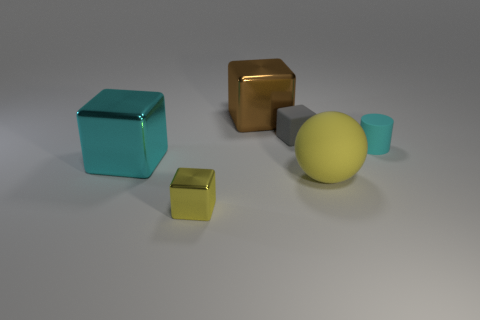The yellow thing on the right side of the block that is behind the small gray cube is what shape?
Your response must be concise. Sphere. Is there anything else that has the same size as the yellow rubber ball?
Keep it short and to the point. Yes. There is a yellow object that is on the right side of the tiny cube that is behind the yellow object that is on the left side of the yellow matte sphere; what is its shape?
Your response must be concise. Sphere. What number of objects are things that are behind the small gray matte thing or things that are behind the yellow shiny thing?
Ensure brevity in your answer.  5. There is a gray matte thing; is it the same size as the yellow object that is left of the yellow matte ball?
Give a very brief answer. Yes. Are the tiny cube that is in front of the cyan matte object and the gray cube to the right of the small metallic thing made of the same material?
Provide a succinct answer. No. Are there the same number of big shiny blocks that are left of the brown object and cyan shiny cubes that are behind the small yellow thing?
Provide a succinct answer. Yes. What number of tiny metallic cubes have the same color as the large sphere?
Provide a succinct answer. 1. There is a big object that is the same color as the tiny rubber cylinder; what is its material?
Make the answer very short. Metal. What number of matte objects are either large brown blocks or big cylinders?
Your answer should be very brief. 0. 